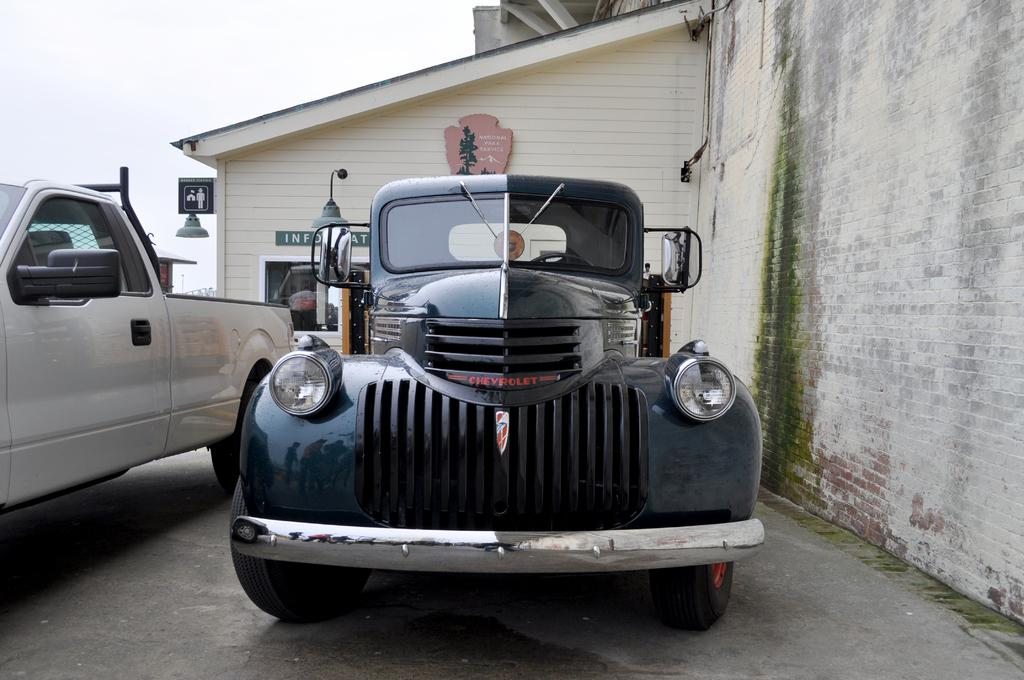What can be seen on the path in the image? There are vehicles on the path in the image. What is on the house in the image? There are boards on a house in the image. What type of growth is present on the wall in the image? There is green algae on a wall in the image. What type of hair can be seen on the vehicles in the image? There is no hair present on the vehicles in the image. Can you describe the flight of the algae on the wall in the image? There is no flight involved, as the algae is stationary on the wall in the image. 